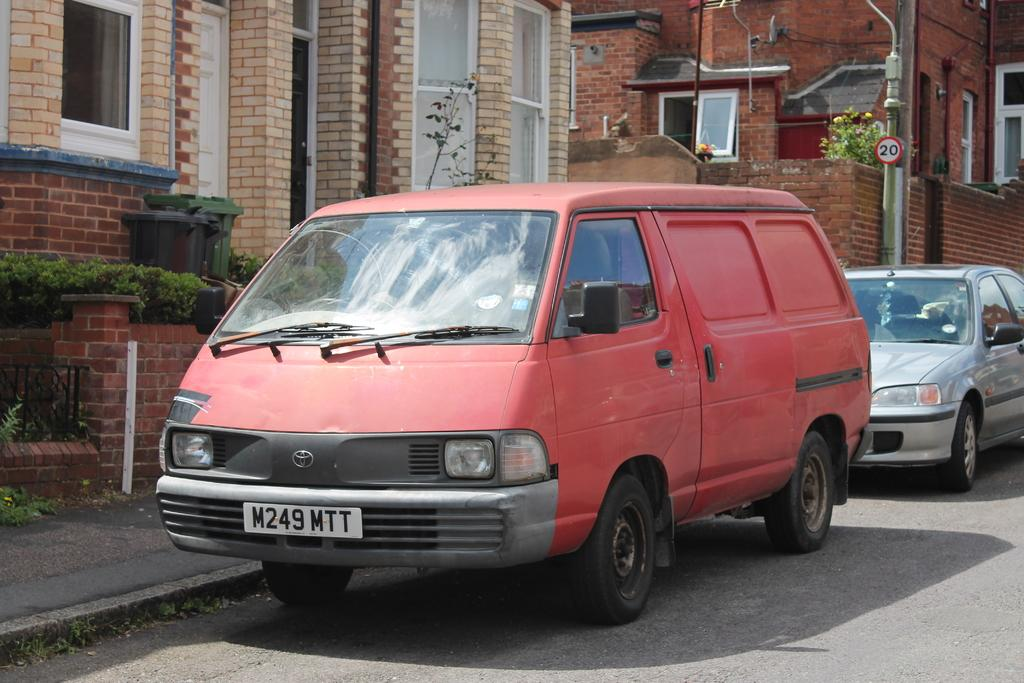Provide a one-sentence caption for the provided image. A red van is parked on the side of the road. 